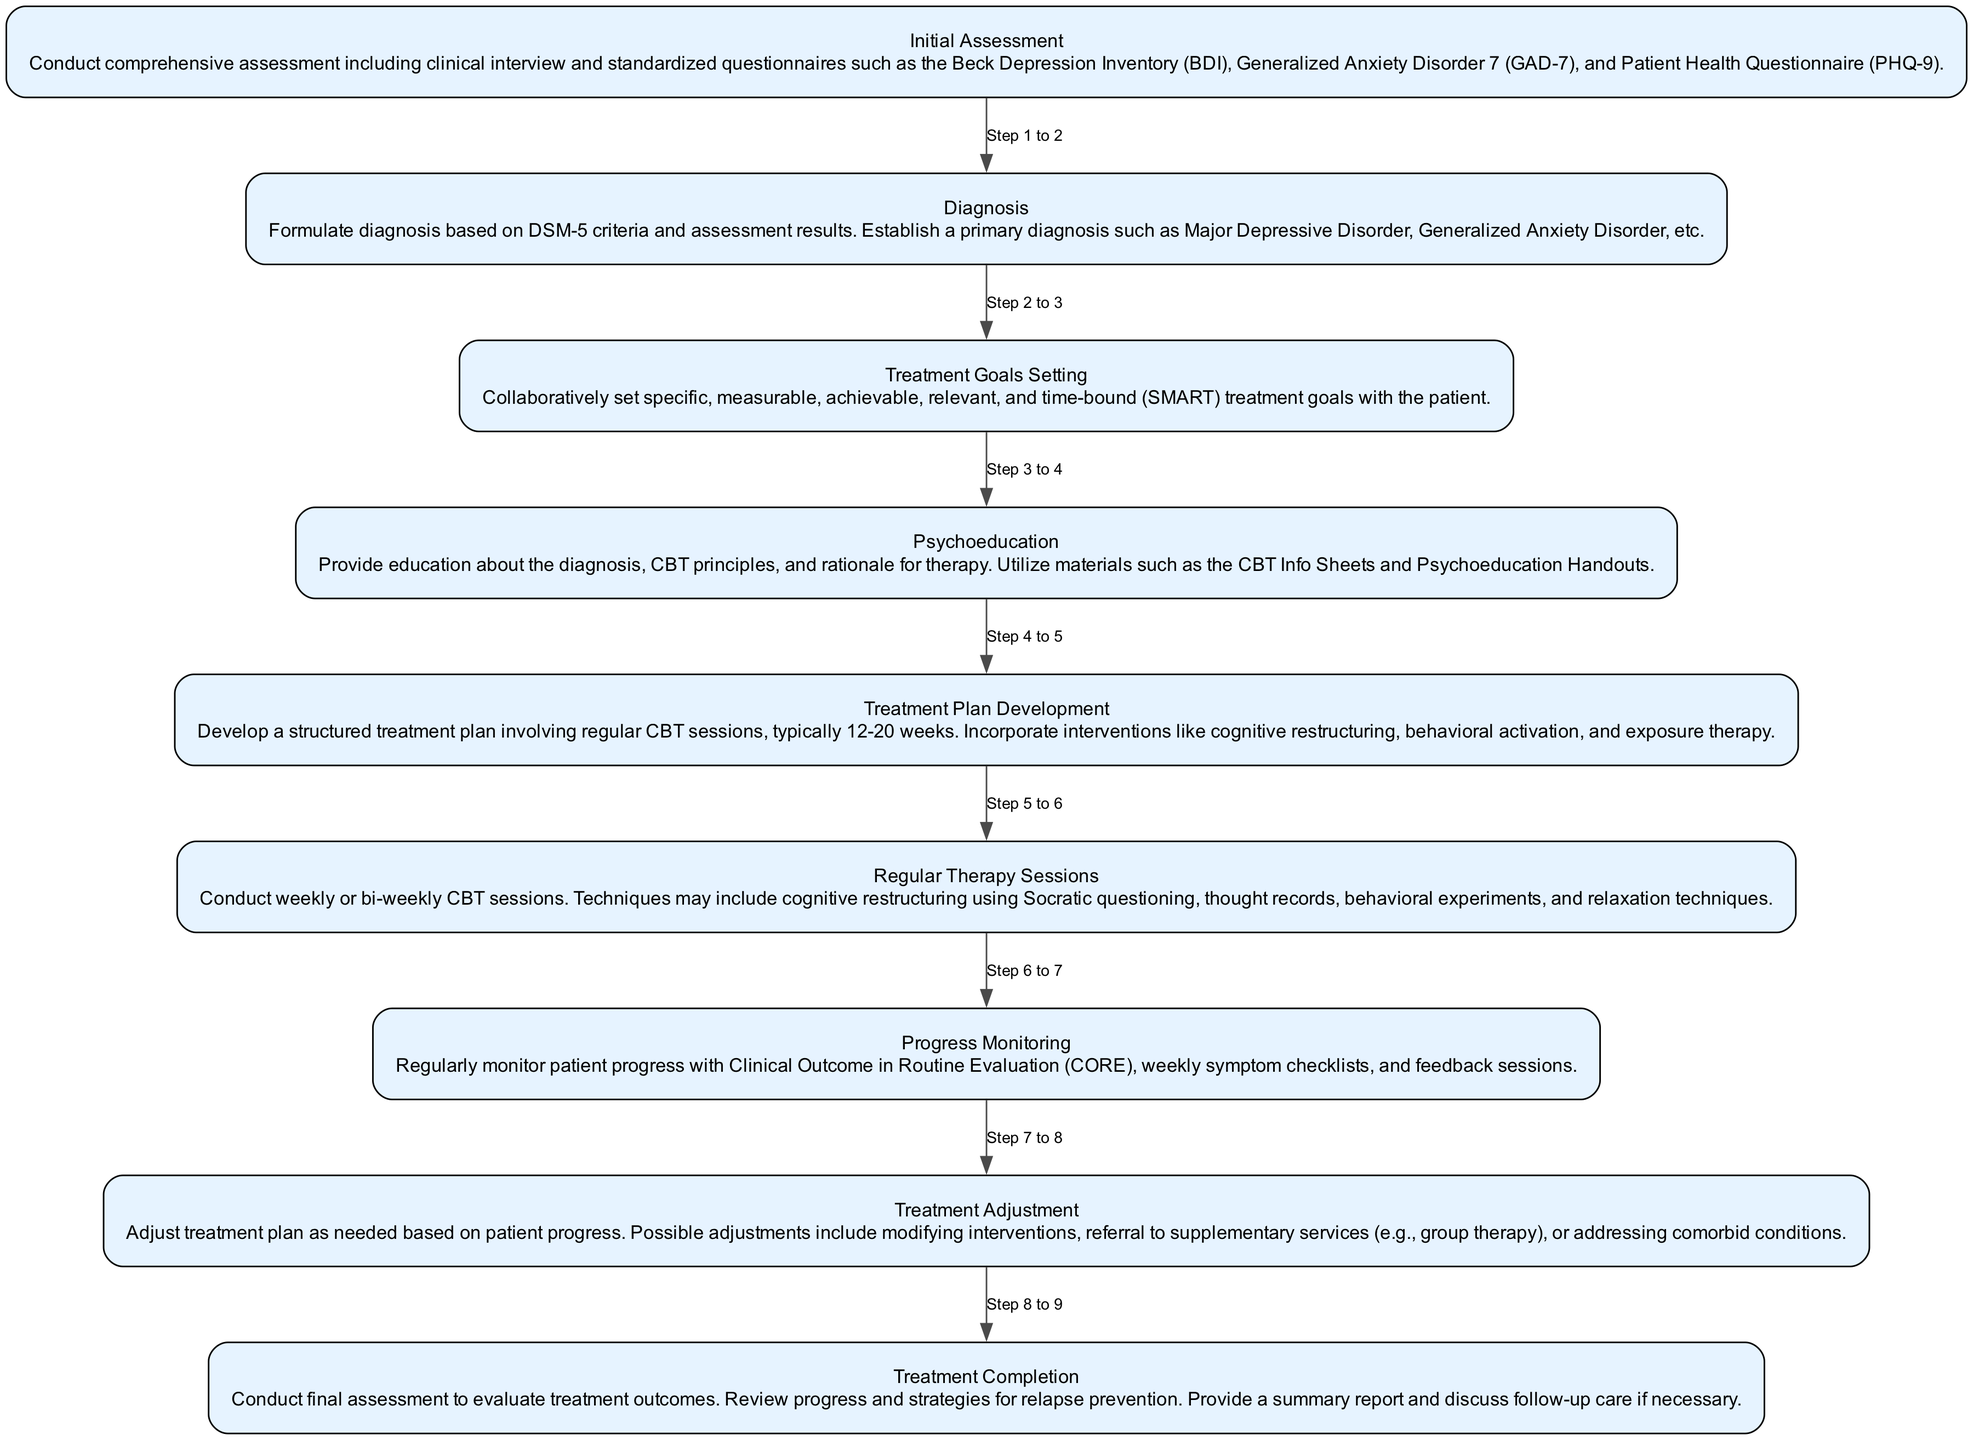What is the first step in the CBT pathway? The diagram clearly indicates that the first step is labeled "Initial Assessment," which is the starting point of the pathway.
Answer: Initial Assessment How many steps are in the CBT pathway? By counting the nodes in the diagram, including the start and end points, there are a total of eight steps in the Cognitive Behavioral Therapy pathway.
Answer: Eight What comes after "Psychoeducation" in the pathway? The diagram shows an arrow pointing from "Psychoeducation" to the next step, which is "Treatment Plan Development." This is a sequential relationship in the pathway.
Answer: Treatment Plan Development What is the purpose of the "Monitoring" step? The description of "Monitoring" in the diagram suggests that this step involves regularly checking the patient's progress with various evaluation tools to ensure effective treatment.
Answer: Regularly monitor patient progress What does "Goal Setting" refer to in this pathway? In the pathway, "Goal Setting" refers to the collaborative process of establishing SMART treatment goals, as indicated in the step description.
Answer: Collaborative goal setting How is the treatment adjusted based on patient progress? The diagram states that the "Adjustment" step involves modifying the treatment plan according to the patient's progress, which may include changing interventions or referring to additional services.
Answer: Modify treatment plan as needed What two assessment tools are mentioned in the "Initial Assessment"? The "Initial Assessment" identifies standardized questionnaires including the Beck Depression Inventory (BDI) and the Generalized Anxiety Disorder 7 (GAD-7) as tools used during evaluation.
Answer: Beck Depression Inventory and Generalized Anxiety Disorder 7 What is the final step in the CBT pathway? The diagram explicitly states that the final step is "Treatment Completion," which represents the conclusion of the therapy process.
Answer: Treatment Completion What does the "Adjustment" step involve? According to the description in the diagram, the "Adjustment" step may include changing interventions or addressing comorbid conditions based on the patient's ongoing progress.
Answer: Modifying interventions or addressing comorbid conditions 